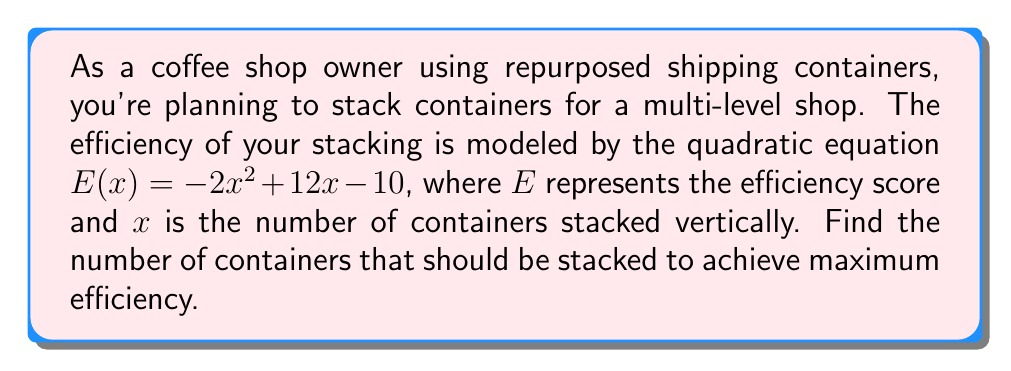Can you answer this question? To find the number of containers that should be stacked for maximum efficiency, we need to find the roots of the derivative of the efficiency function. This will give us the x-coordinate of the vertex of the parabola, which represents the maximum point.

1. Start with the given quadratic equation:
   $E(x) = -2x^2 + 12x - 10$

2. Find the derivative of $E(x)$:
   $E'(x) = -4x + 12$

3. Set the derivative equal to zero to find the critical point:
   $-4x + 12 = 0$

4. Solve for x:
   $-4x = -12$
   $x = 3$

5. To confirm this is a maximum (not a minimum), we can check the second derivative:
   $E''(x) = -4$, which is negative, confirming a maximum.

6. The quadratic equation can be rewritten in vertex form to verify:
   $E(x) = -2(x^2 - 6x) - 10$
   $E(x) = -2((x - 3)^2 - 9) - 10$
   $E(x) = -2(x - 3)^2 + 18 - 10$
   $E(x) = -2(x - 3)^2 + 8$

This form confirms that the vertex is at $x = 3$.

Therefore, the maximum efficiency is achieved when 3 containers are stacked vertically.
Answer: 3 containers 